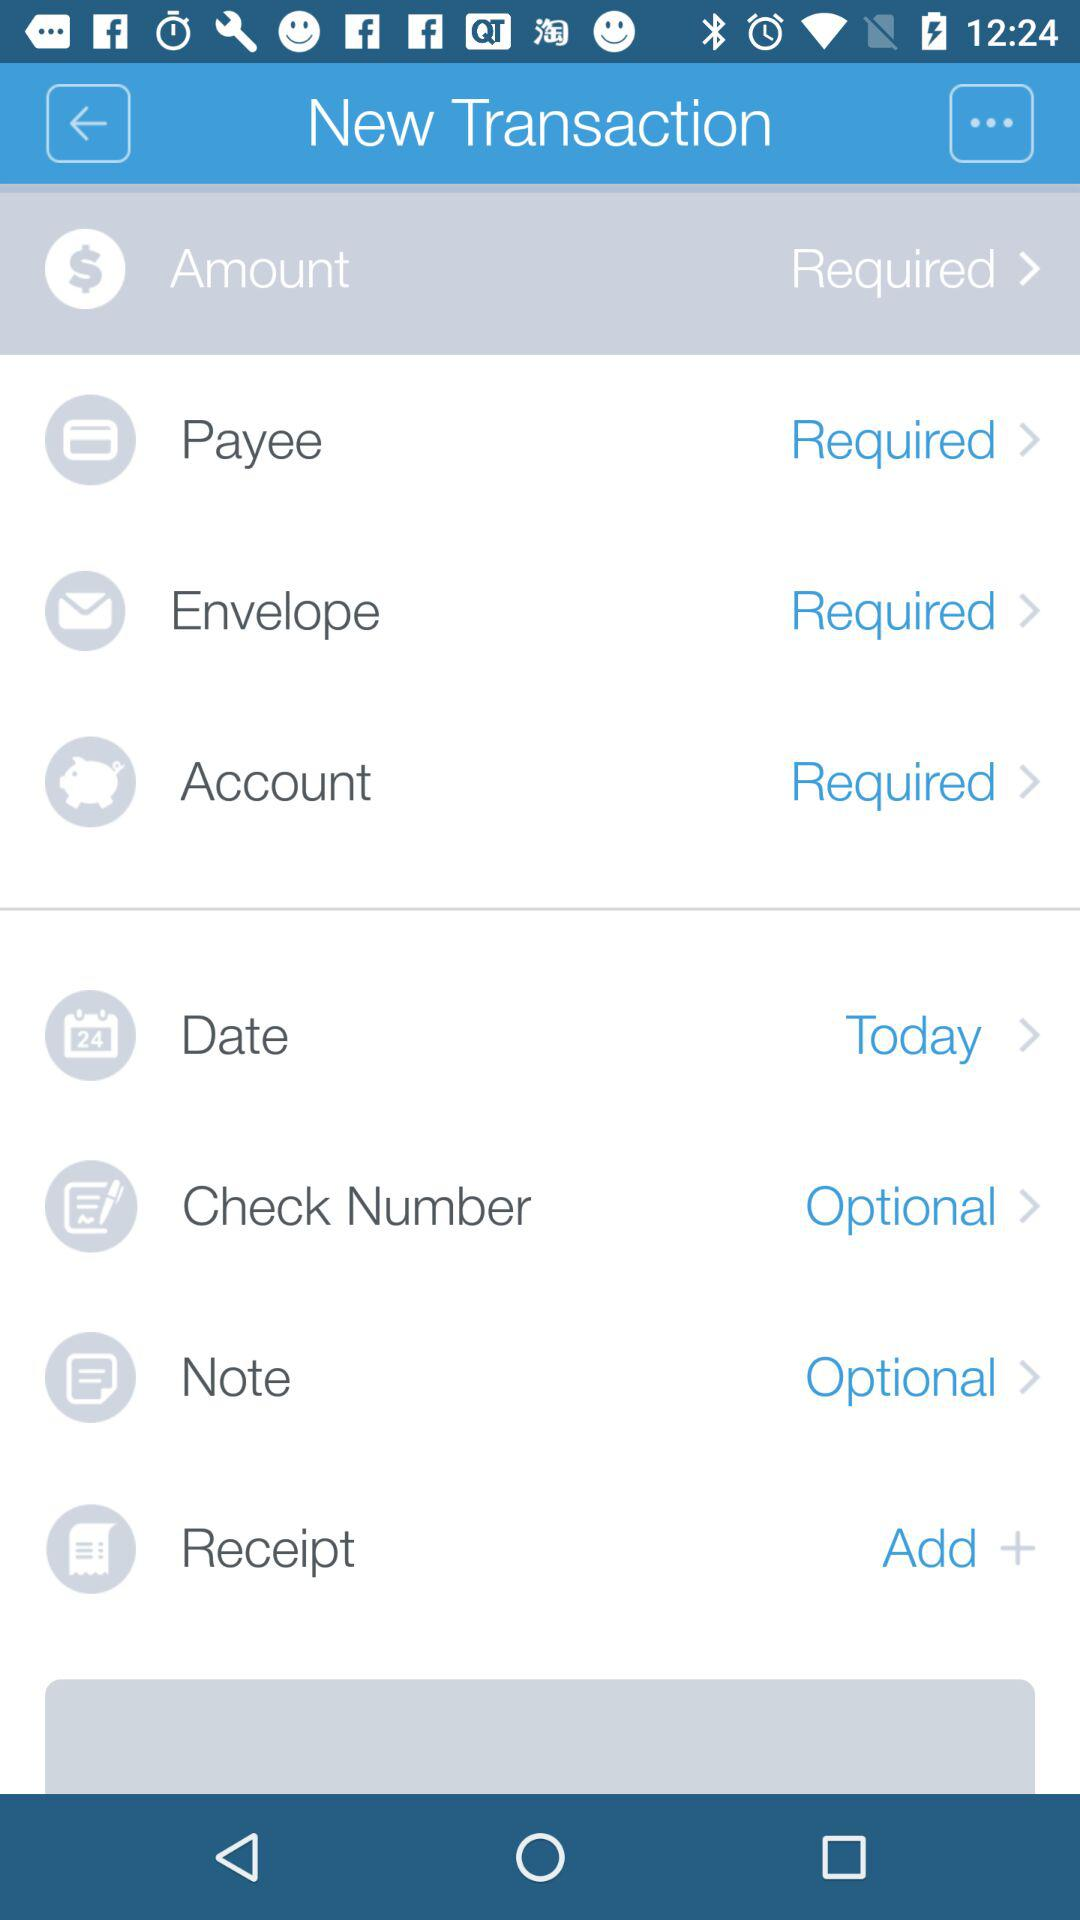How many items are optional?
Answer the question using a single word or phrase. 2 